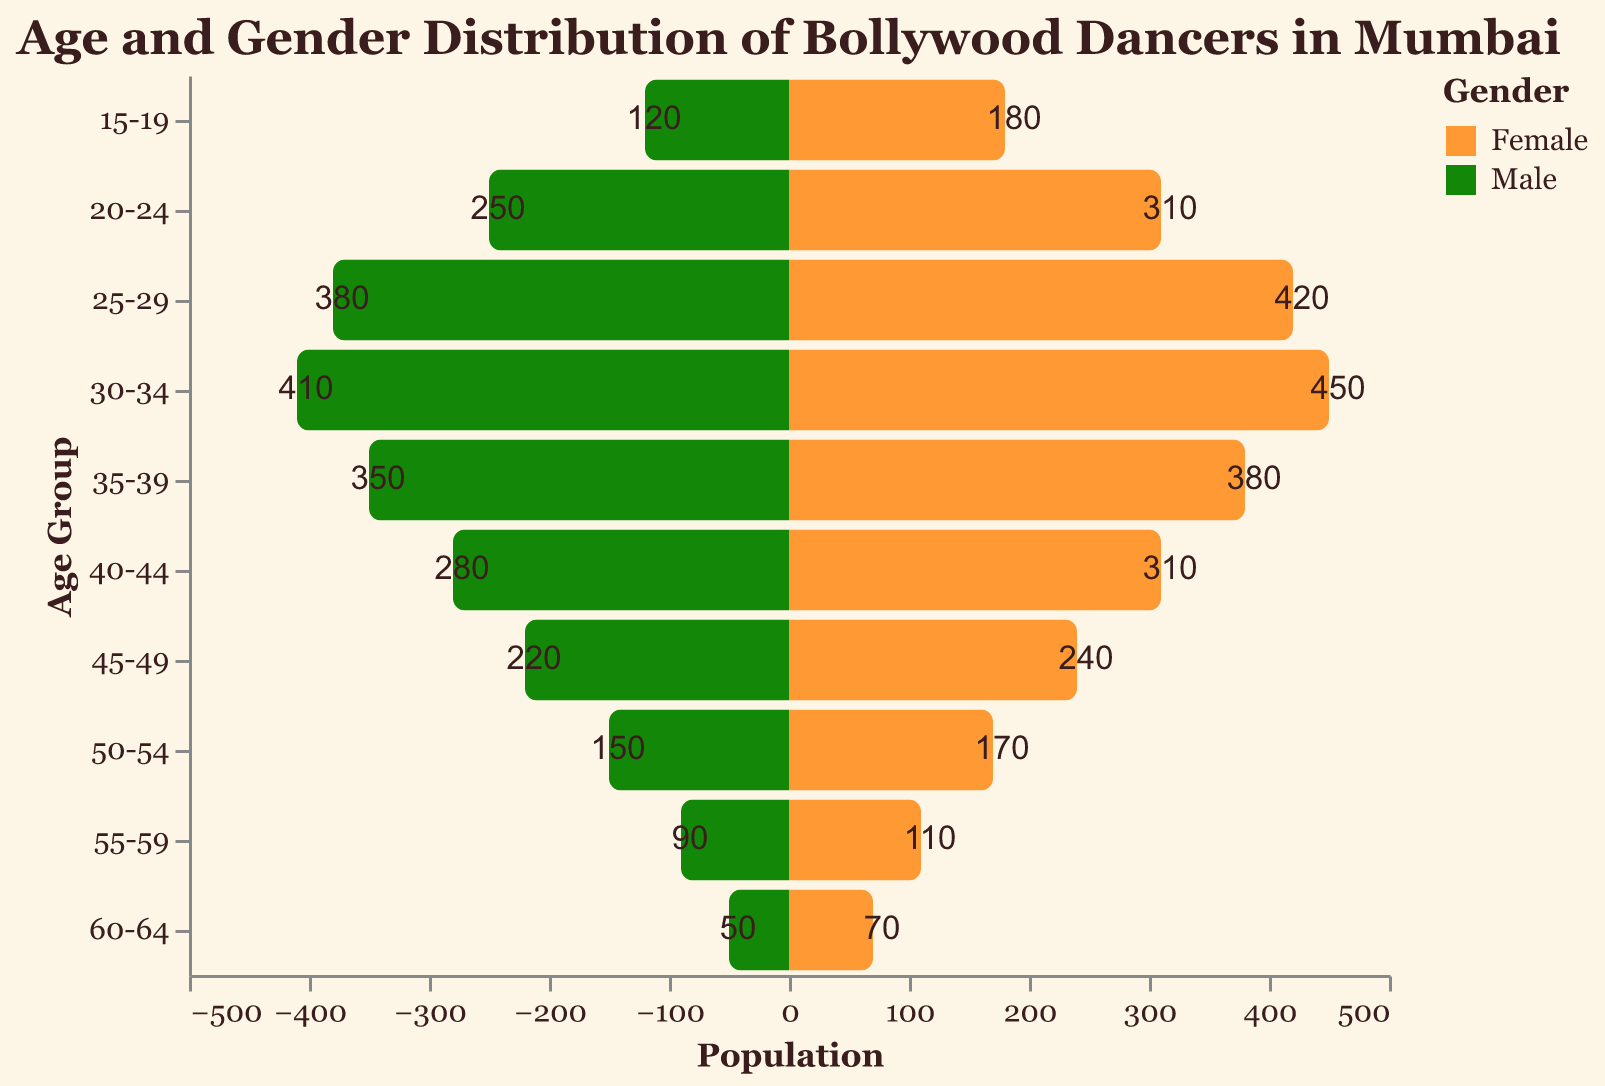What is the total population of dancers in the 30-34 age group? The population of male dancers in the 30-34 age group is 410, and the population of female dancers is 450. Adding these two values together gives a total population of 410 + 450 = 860.
Answer: 860 In which age group is the female dancer population the highest? To determine this, look for the highest value in the female column. The female dancer population is highest in the 30-34 age group with a population of 450.
Answer: 30-34 Which gender has a higher population in the 25-29 age group? In the 25-29 age group, there are 380 male dancers and 420 female dancers. Since 420 is greater than 380, the female population is higher in this age group.
Answer: Female How many more female dancers are there than male dancers in the 20-24 age group? The number of female dancers in the 20-24 age group is 310, while the number of male dancers is 250. The difference is 310 - 250 = 60.
Answer: 60 What is the difference in the male dancer population between the 15-19 and 30-34 age groups? The male dancer population in the 15-19 age group is 120, and in the 30-34 age group, it is 410. The difference is 410 - 120 = 290.
Answer: 290 Which age group has the smallest total population of dancers? Adding the male and female populations for each age group, we find the smallest total population in the 60-64 age group, with 50 males and 70 females, giving a total of 120.
Answer: 60-64 How does the population of male dancers in the 35-39 age group compare to the population of female dancers in the same age group? In the 35-39 age group, there are 350 male dancers and 380 female dancers. Since 380 is greater than 350, the female population is larger.
Answer: Female What is the ratio of male to female dancers in the 40-44 age group? The number of male dancers in the 40-44 age group is 280, and the number of female dancers is 310. The ratio of male to female dancers is 280:310, which simplifies to 28:31.
Answer: 28:31 